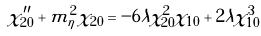Convert formula to latex. <formula><loc_0><loc_0><loc_500><loc_500>\chi _ { 2 0 } ^ { \prime \prime } + m _ { \eta } ^ { 2 } \chi _ { 2 0 } = - 6 \lambda \chi _ { 2 0 } ^ { 2 } \chi _ { 1 0 } + 2 \lambda \chi _ { 1 0 } ^ { 3 }</formula> 